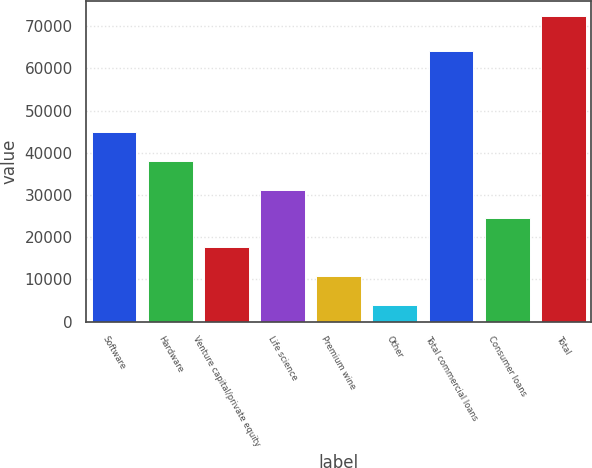<chart> <loc_0><loc_0><loc_500><loc_500><bar_chart><fcel>Software<fcel>Hardware<fcel>Venture capital/private equity<fcel>Life science<fcel>Premium wine<fcel>Other<fcel>Total commercial loans<fcel>Consumer loans<fcel>Total<nl><fcel>45020.8<fcel>38163.5<fcel>17591.6<fcel>31306.2<fcel>10734.3<fcel>3877<fcel>64247<fcel>24448.9<fcel>72450<nl></chart> 